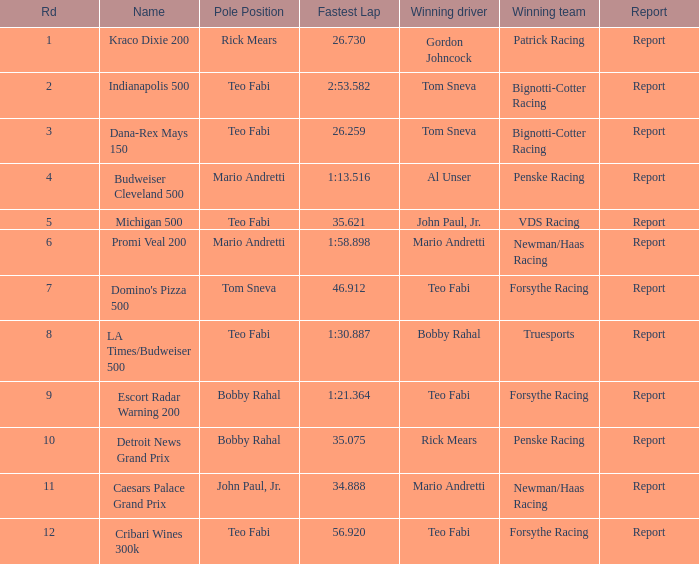What is the highest Rd that Tom Sneva had the pole position in? 7.0. 